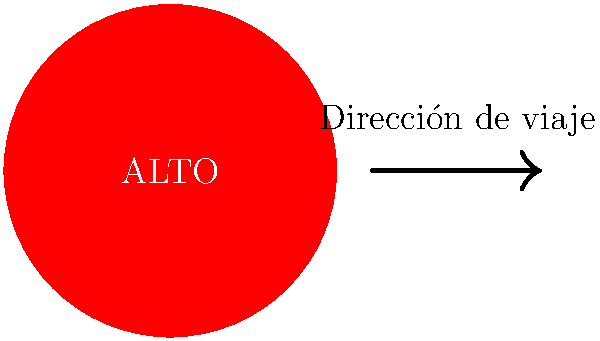You encounter this road sign while driving in Mexico. What action should you take, and what is the English translation of the text on the sign? To interpret this road sign correctly, let's break it down step-by-step:

1. Shape and Color: The sign is circular with a red background, which typically indicates a prohibitory or mandatory action.

2. Text: The word "ALTO" is written in white letters on the red background.

3. Translation: "ALTO" in Spanish translates to "STOP" in English.

4. Meaning: This sign is equivalent to the octagonal stop sign used in many other countries, including the United States.

5. Required Action: When encountering this sign, drivers must come to a complete stop before proceeding.

6. Cultural Context: In Mexico, it's common to see this circular red sign with "ALTO" instead of the octagonal shape used in some other countries.

7. Safety Consideration: As a retiree on a solo road trip, it's crucial to obey these signs to ensure your safety and comply with local traffic laws.

Therefore, upon seeing this sign, you should come to a complete stop before proceeding, just as you would with a stop sign in other countries.
Answer: Stop; "STOP" 